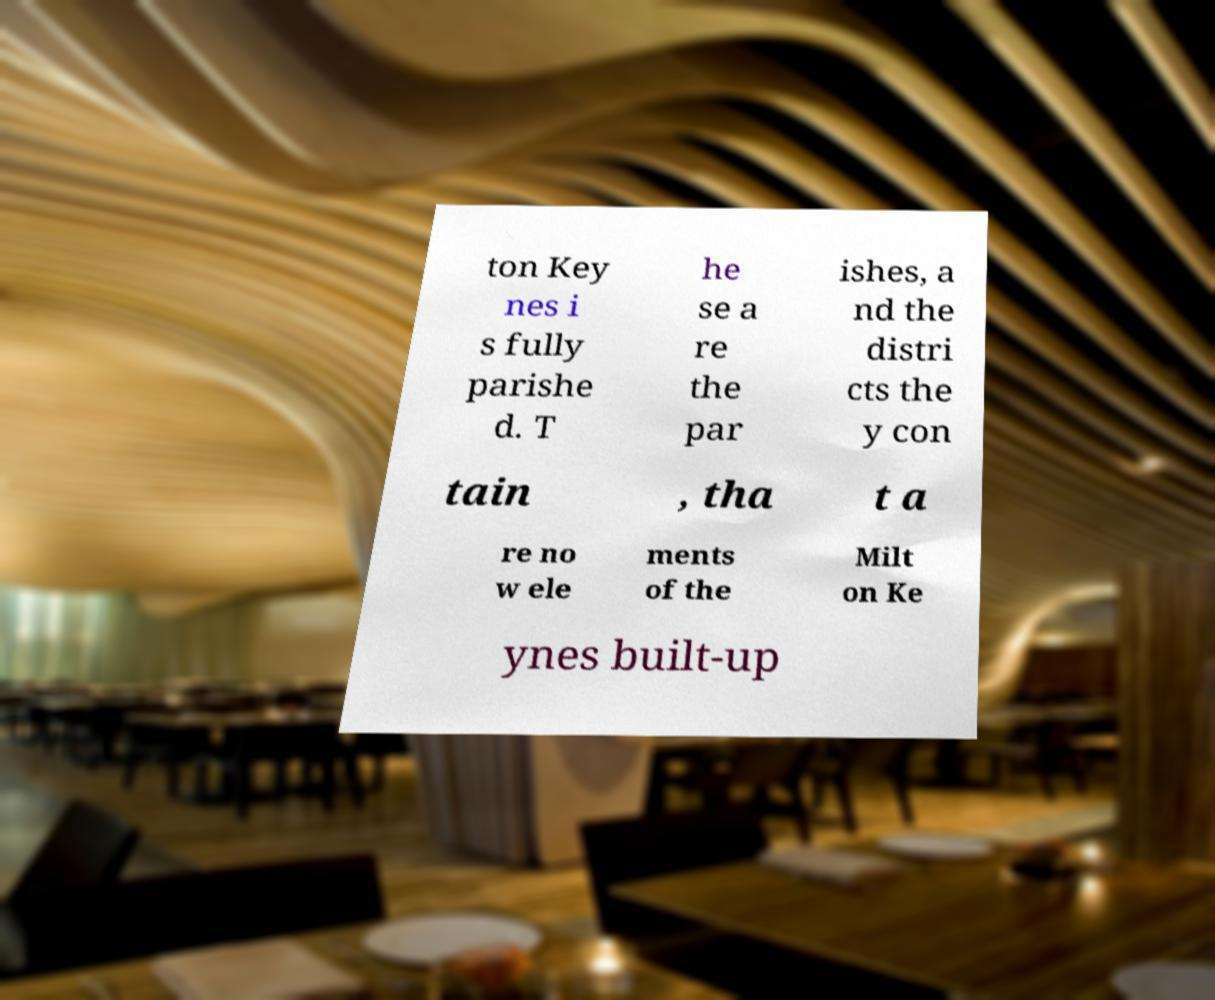I need the written content from this picture converted into text. Can you do that? ton Key nes i s fully parishe d. T he se a re the par ishes, a nd the distri cts the y con tain , tha t a re no w ele ments of the Milt on Ke ynes built-up 